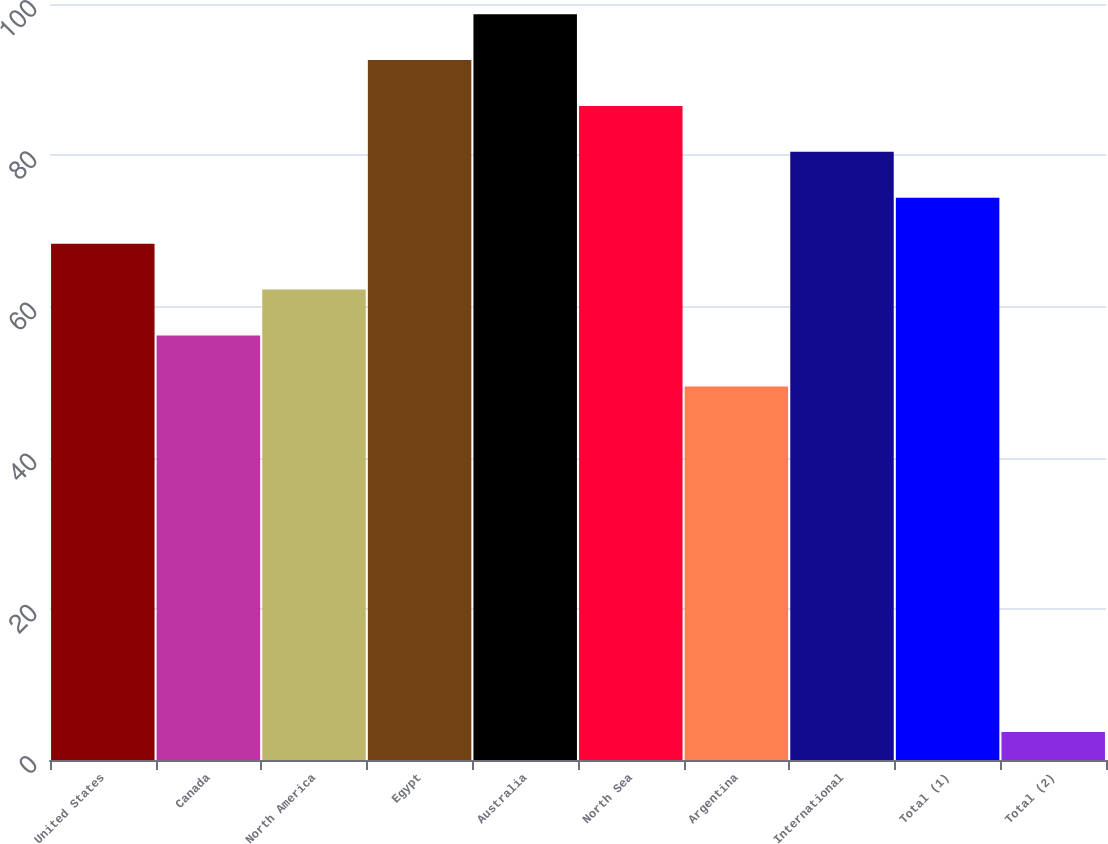Convert chart to OTSL. <chart><loc_0><loc_0><loc_500><loc_500><bar_chart><fcel>United States<fcel>Canada<fcel>North America<fcel>Egypt<fcel>Australia<fcel>North Sea<fcel>Argentina<fcel>International<fcel>Total (1)<fcel>Total (2)<nl><fcel>68.3<fcel>56.16<fcel>62.23<fcel>92.58<fcel>98.65<fcel>86.51<fcel>49.42<fcel>80.44<fcel>74.37<fcel>3.69<nl></chart> 